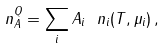Convert formula to latex. <formula><loc_0><loc_0><loc_500><loc_500>n _ { A } ^ { Q } = \sum _ { i } A _ { i } \ n _ { i } ( T , \mu _ { i } ) \, ,</formula> 